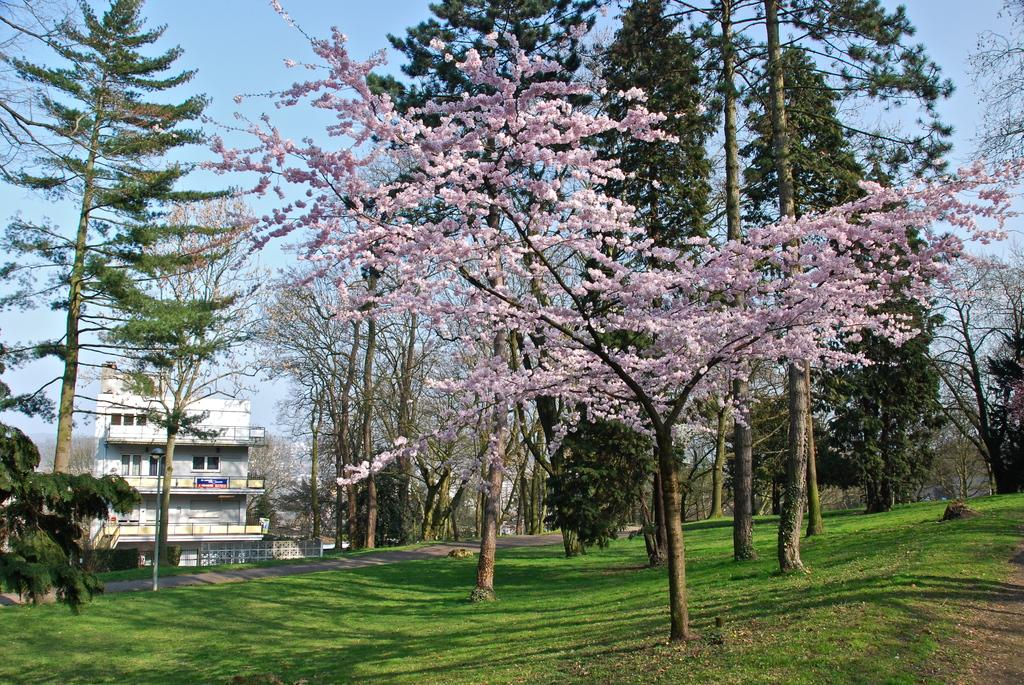What type of vegetation is visible in the image? There is grass in the image. What other types of plants can be seen in the image? There are flowers and trees visible in the image. What is visible in the background of the image? There is a building in the background of the image. Can you tell me what the men are discussing about the brain in the image? There are no men or discussion about the brain present in the image. What type of brain activity can be observed in the image? There is no brain or brain activity present in the image; it features grass, flowers, trees, and a building. 